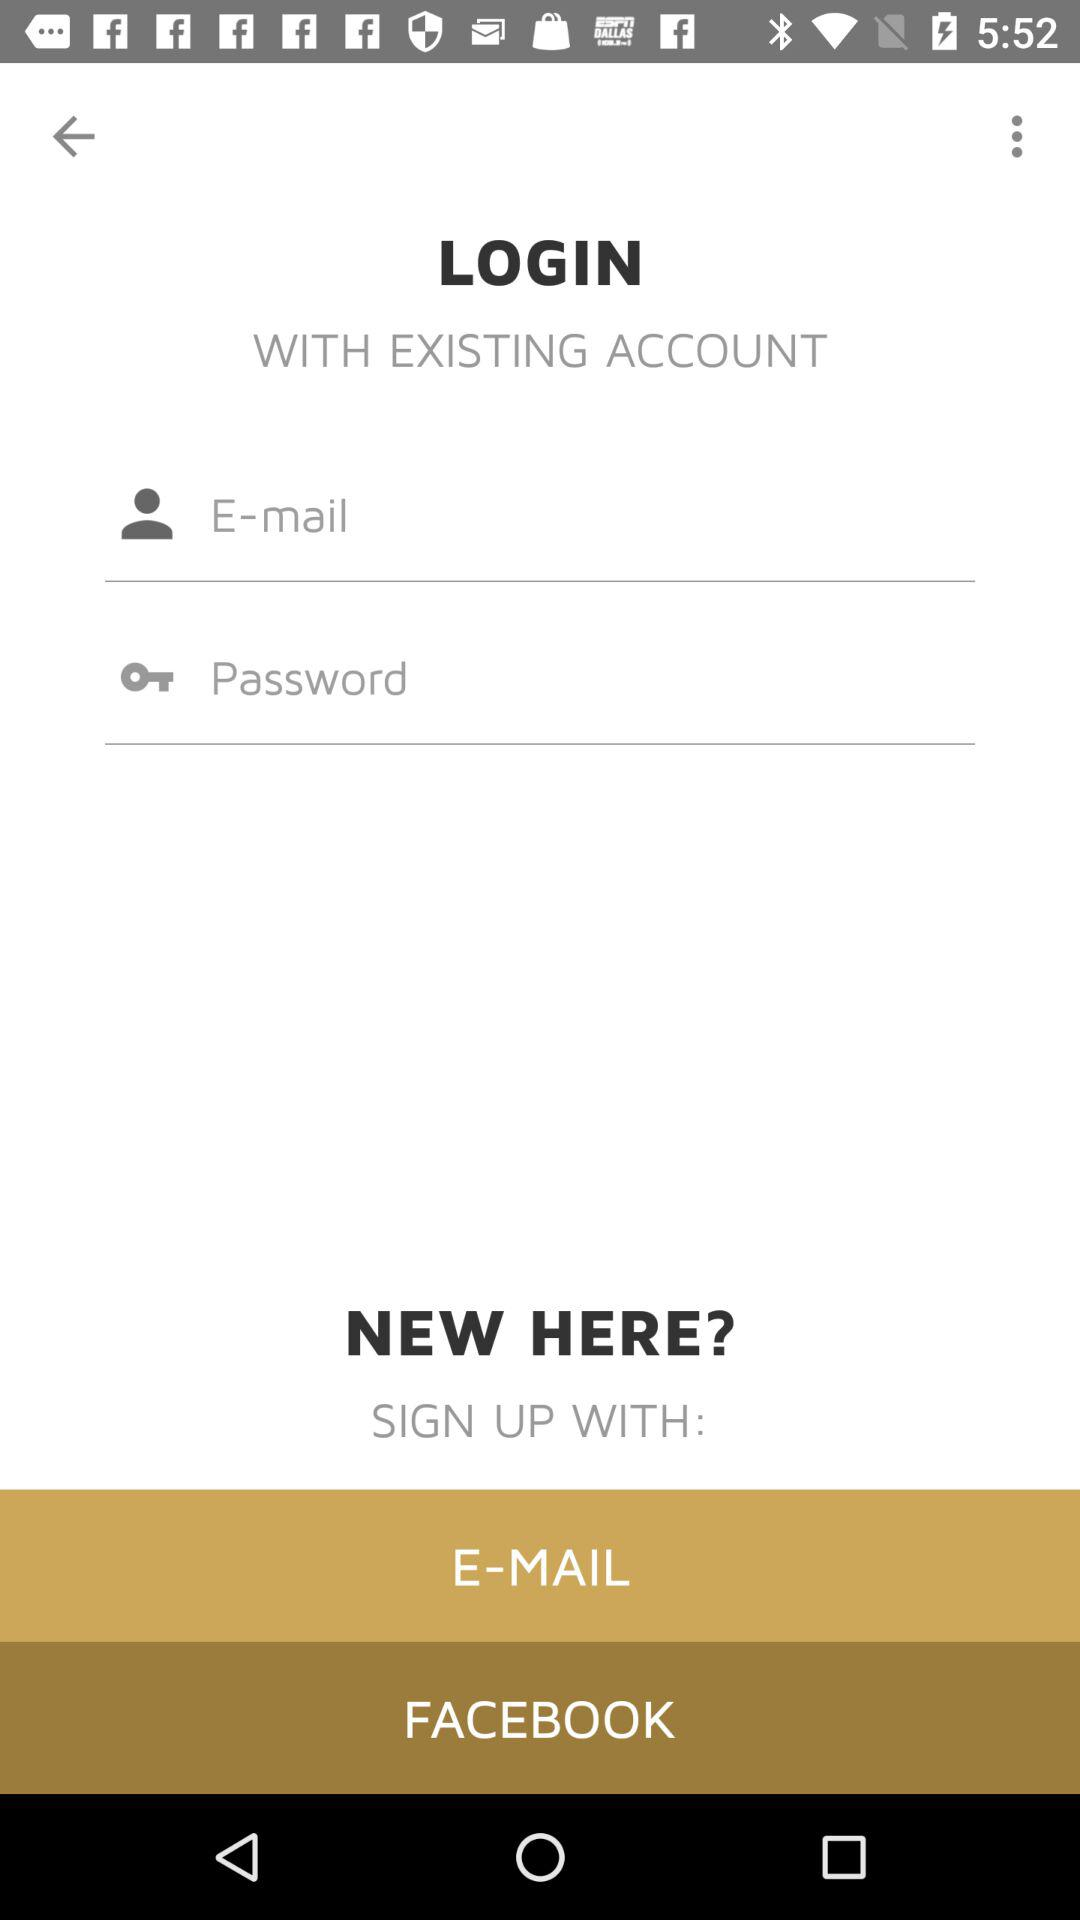What accounts can be used to sign up? The accounts that can be used to sign up are "E-MAIL" and "FACEBOOK". 